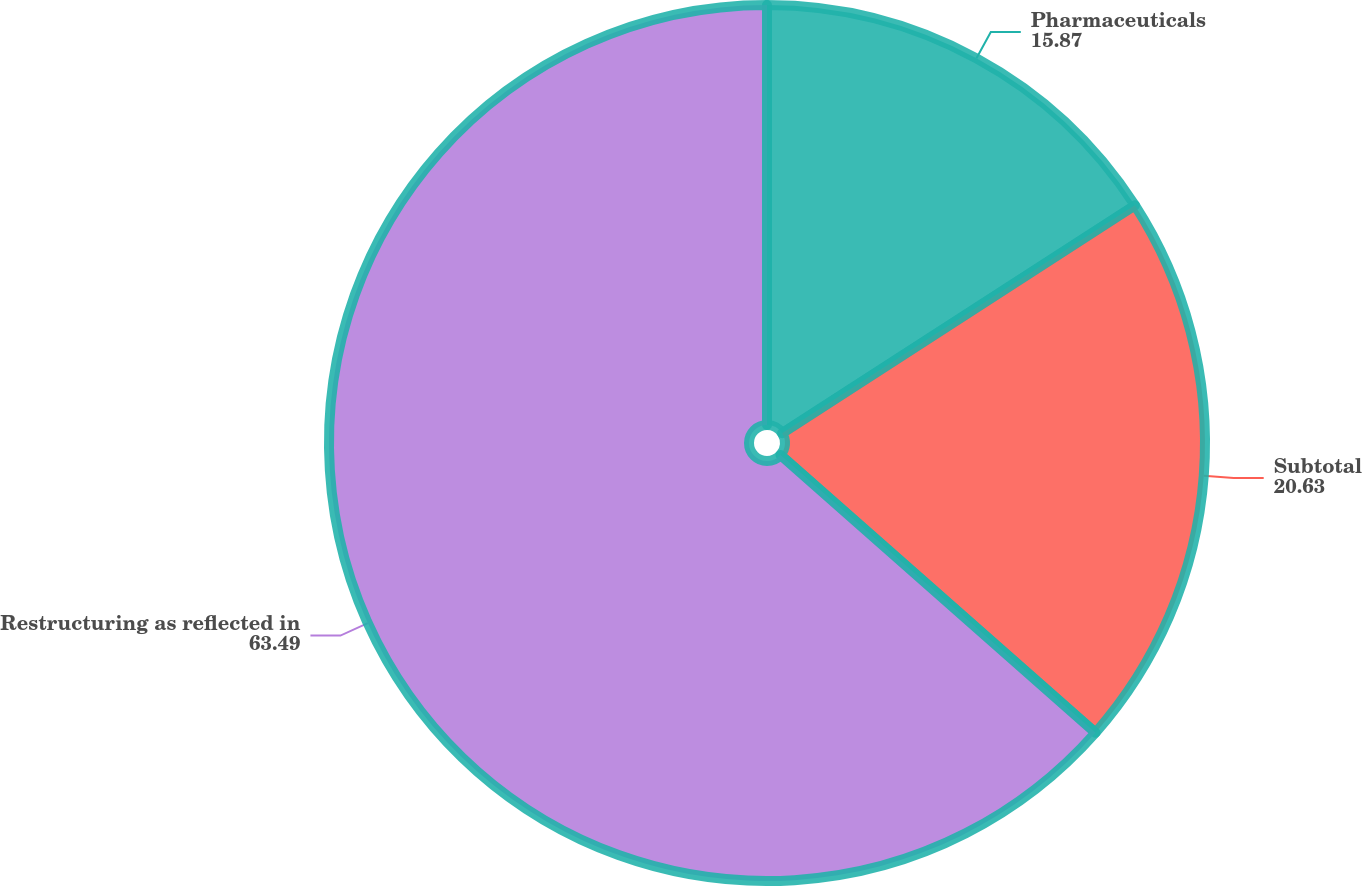Convert chart. <chart><loc_0><loc_0><loc_500><loc_500><pie_chart><fcel>Pharmaceuticals<fcel>Subtotal<fcel>Restructuring as reflected in<nl><fcel>15.87%<fcel>20.63%<fcel>63.49%<nl></chart> 